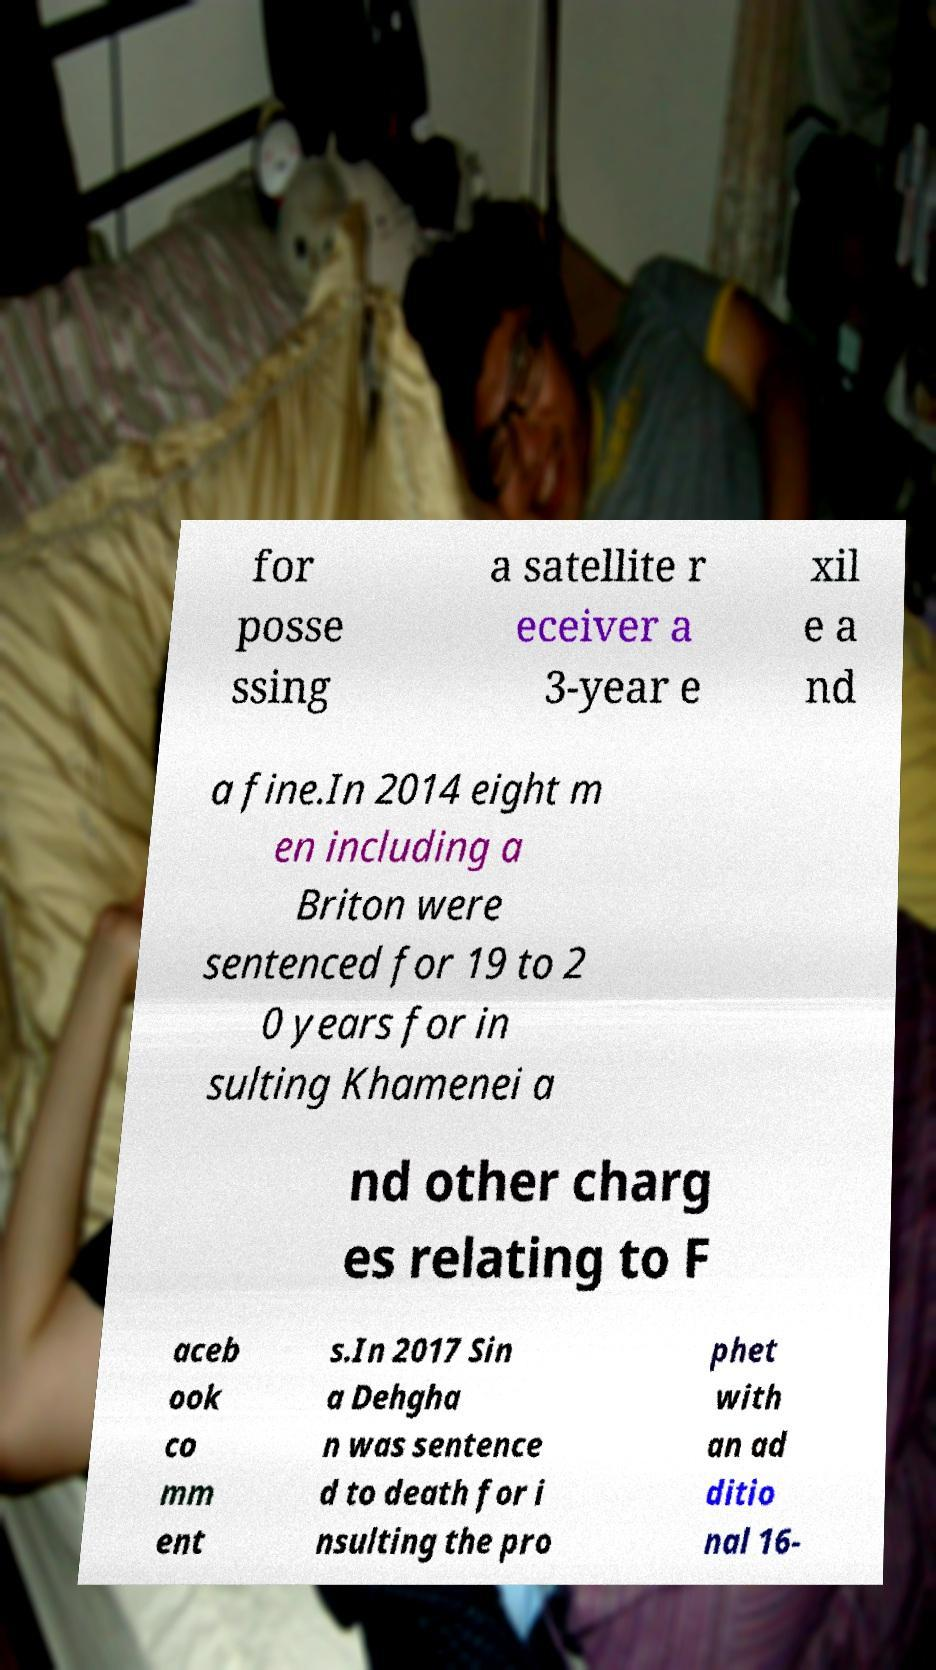Could you assist in decoding the text presented in this image and type it out clearly? for posse ssing a satellite r eceiver a 3-year e xil e a nd a fine.In 2014 eight m en including a Briton were sentenced for 19 to 2 0 years for in sulting Khamenei a nd other charg es relating to F aceb ook co mm ent s.In 2017 Sin a Dehgha n was sentence d to death for i nsulting the pro phet with an ad ditio nal 16- 